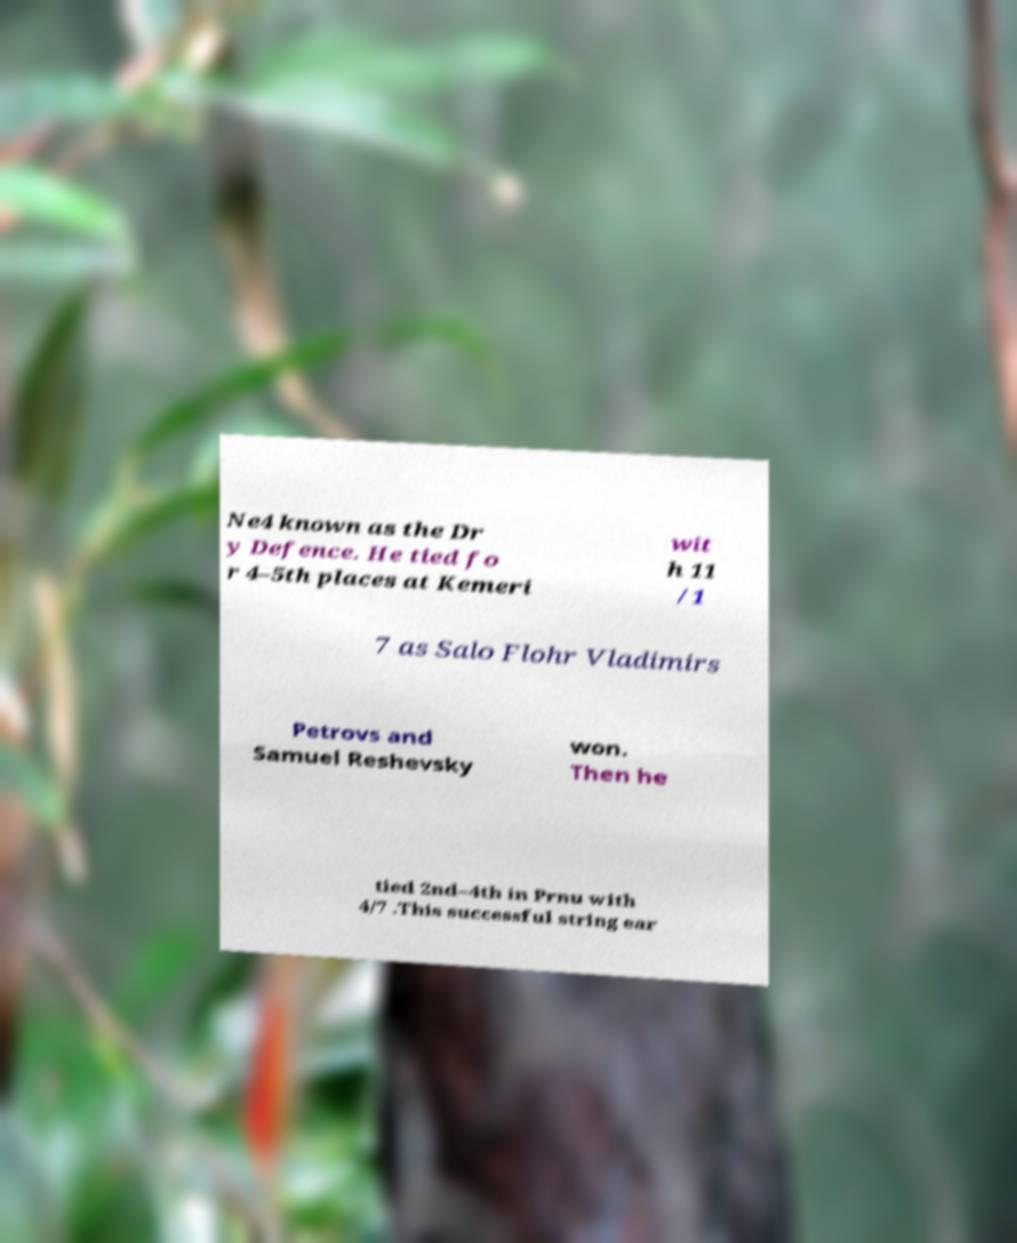I need the written content from this picture converted into text. Can you do that? Ne4 known as the Dr y Defence. He tied fo r 4–5th places at Kemeri wit h 11 /1 7 as Salo Flohr Vladimirs Petrovs and Samuel Reshevsky won. Then he tied 2nd–4th in Prnu with 4/7 .This successful string ear 